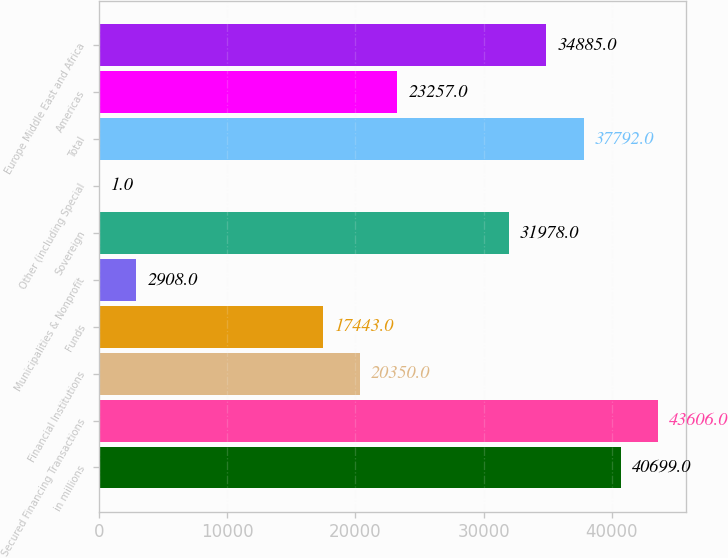Convert chart to OTSL. <chart><loc_0><loc_0><loc_500><loc_500><bar_chart><fcel>in millions<fcel>Secured Financing Transactions<fcel>Financial Institutions<fcel>Funds<fcel>Municipalities & Nonprofit<fcel>Sovereign<fcel>Other (including Special<fcel>Total<fcel>Americas<fcel>Europe Middle East and Africa<nl><fcel>40699<fcel>43606<fcel>20350<fcel>17443<fcel>2908<fcel>31978<fcel>1<fcel>37792<fcel>23257<fcel>34885<nl></chart> 